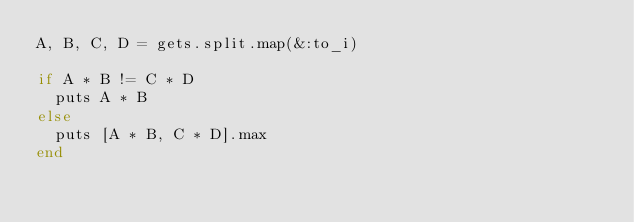<code> <loc_0><loc_0><loc_500><loc_500><_Ruby_>A, B, C, D = gets.split.map(&:to_i)

if A * B != C * D
  puts A * B
else
  puts [A * B, C * D].max
end
</code> 